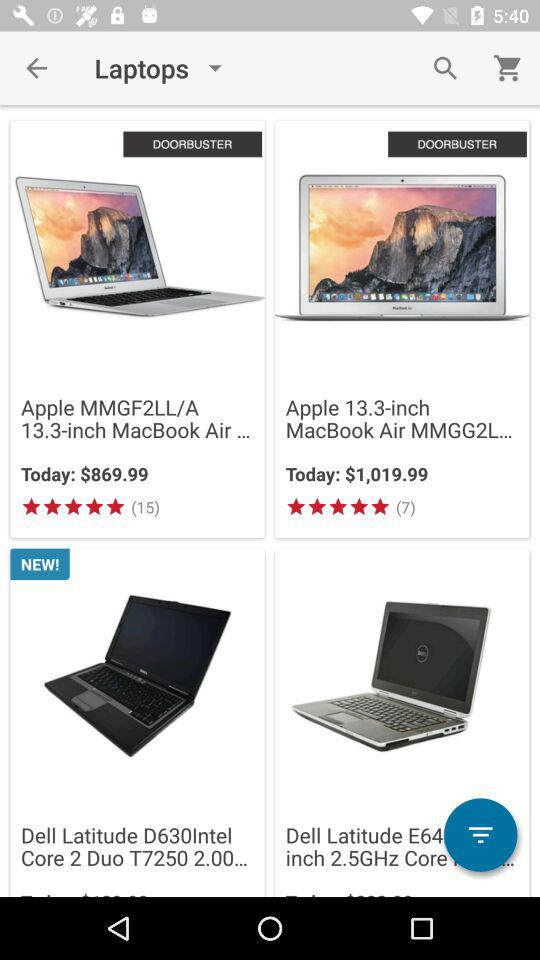Which product is labeled as "NEW!"? The product that is labeled as "NEW!" is "Dell Latitude D630Intel Core 2 Duo T7250 2.00...". 